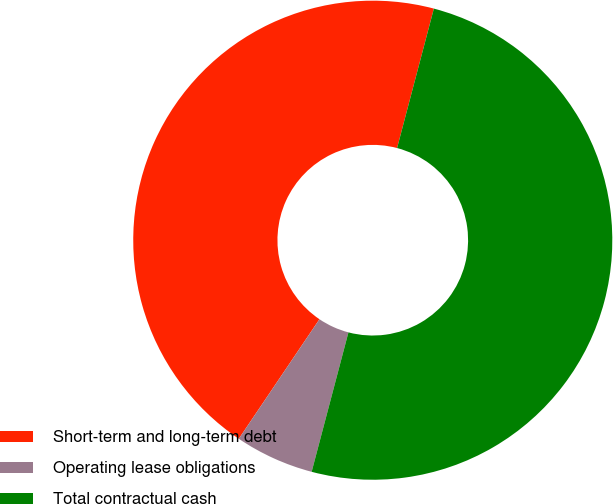Convert chart. <chart><loc_0><loc_0><loc_500><loc_500><pie_chart><fcel>Short-term and long-term debt<fcel>Operating lease obligations<fcel>Total contractual cash<nl><fcel>44.66%<fcel>5.34%<fcel>50.0%<nl></chart> 